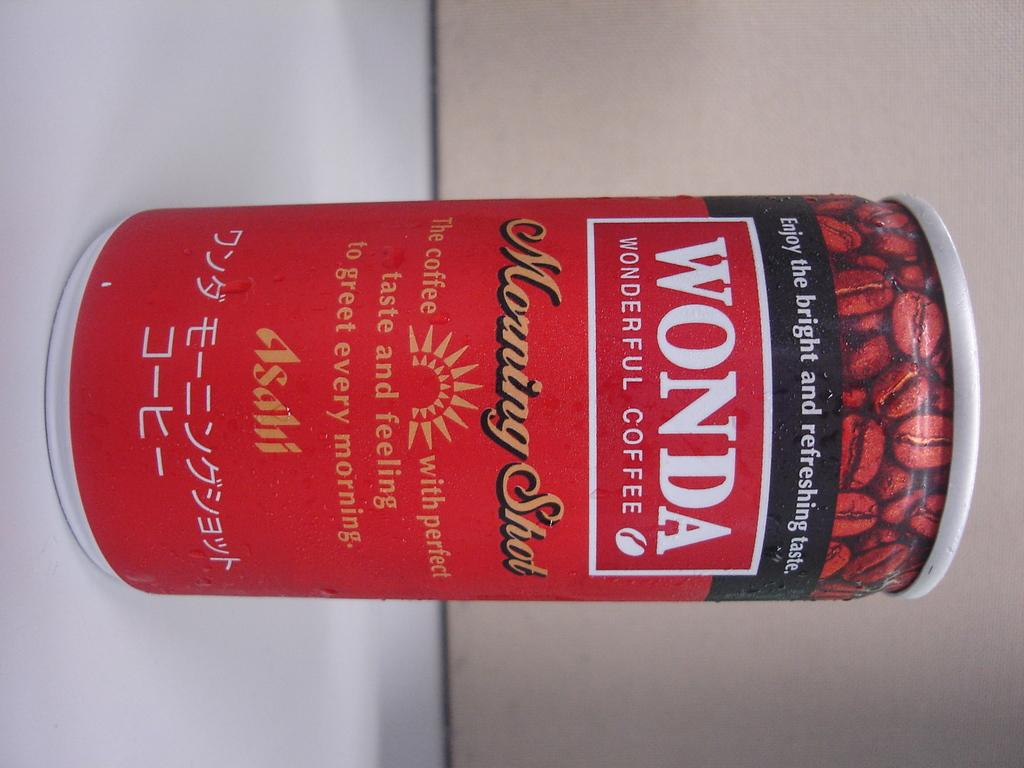<image>
Summarize the visual content of the image. a can of WONDA Wonderful Coffee in Morning Shot flavor 